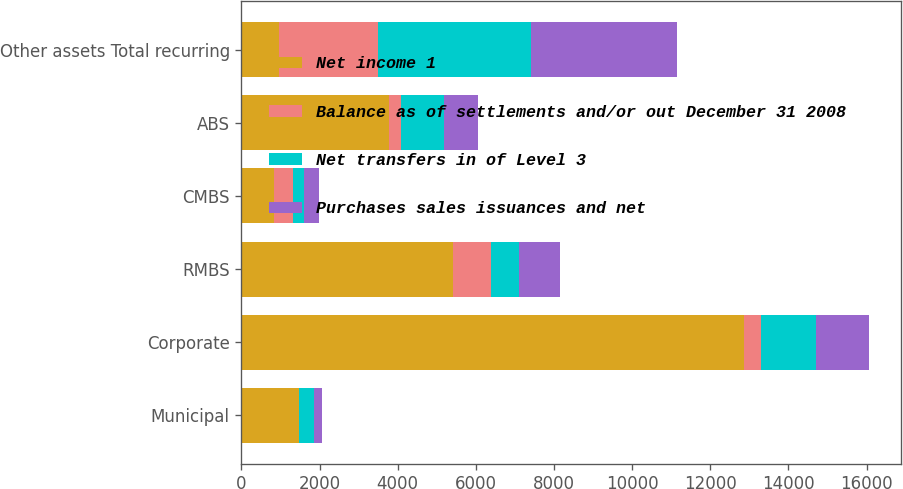<chart> <loc_0><loc_0><loc_500><loc_500><stacked_bar_chart><ecel><fcel>Municipal<fcel>Corporate<fcel>RMBS<fcel>CMBS<fcel>ABS<fcel>Other assets Total recurring<nl><fcel>Net income 1<fcel>1477<fcel>12868<fcel>5405<fcel>833<fcel>3769<fcel>971<nl><fcel>Balance as of settlements and/or out December 31 2008<fcel>3<fcel>426<fcel>971<fcel>479<fcel>316<fcel>2525<nl><fcel>Net transfers in of Level 3<fcel>385<fcel>1402<fcel>731<fcel>291<fcel>1106<fcel>3910<nl><fcel>Purchases sales issuances and net<fcel>205<fcel>1371<fcel>1058<fcel>383<fcel>853<fcel>3732<nl></chart> 